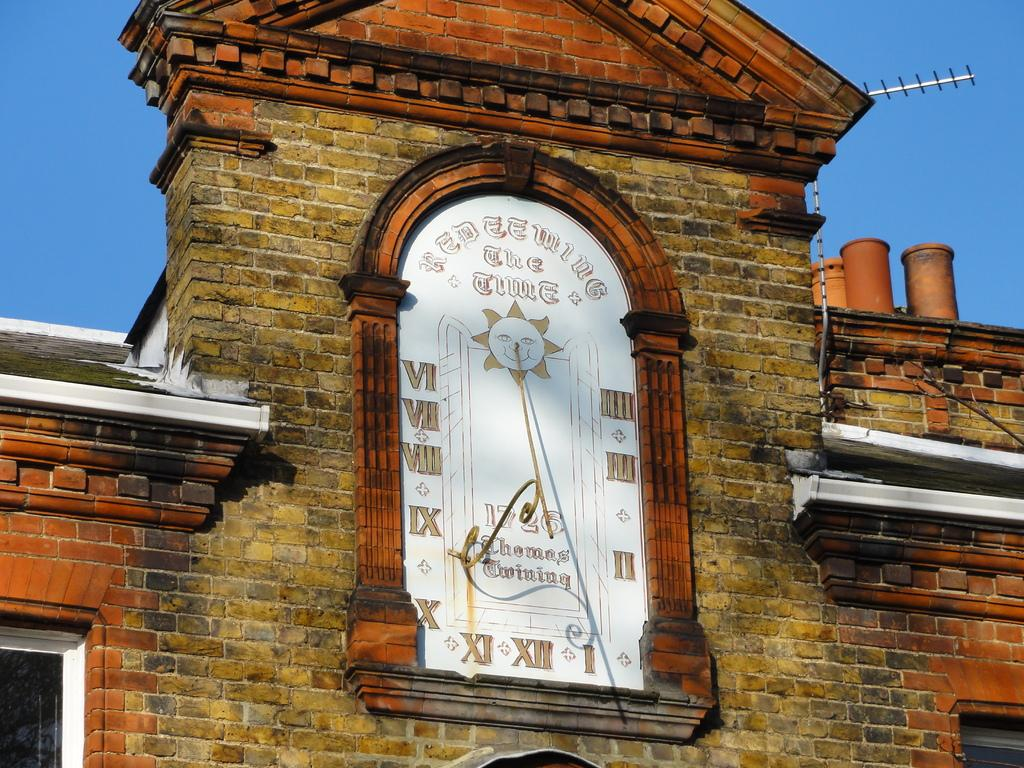Provide a one-sentence caption for the provided image. An old clock with roman numerals on it within an old brick building. 